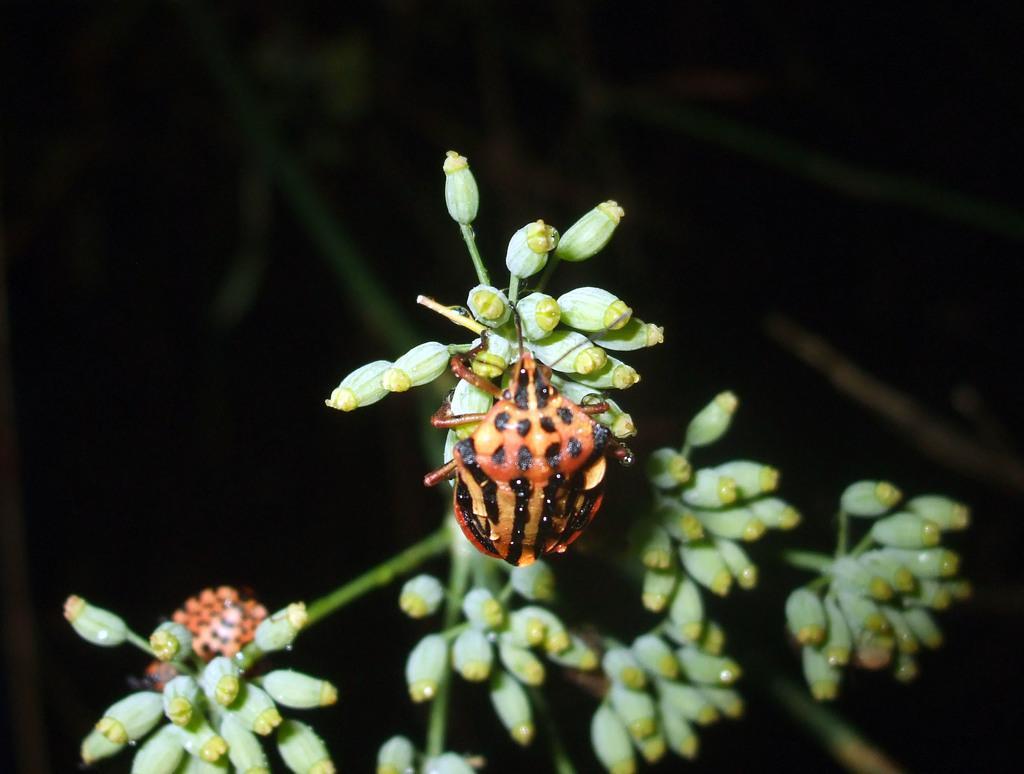In one or two sentences, can you explain what this image depicts? In this picture, we can see an insect which is on the plant. In the background, we can see black color. 